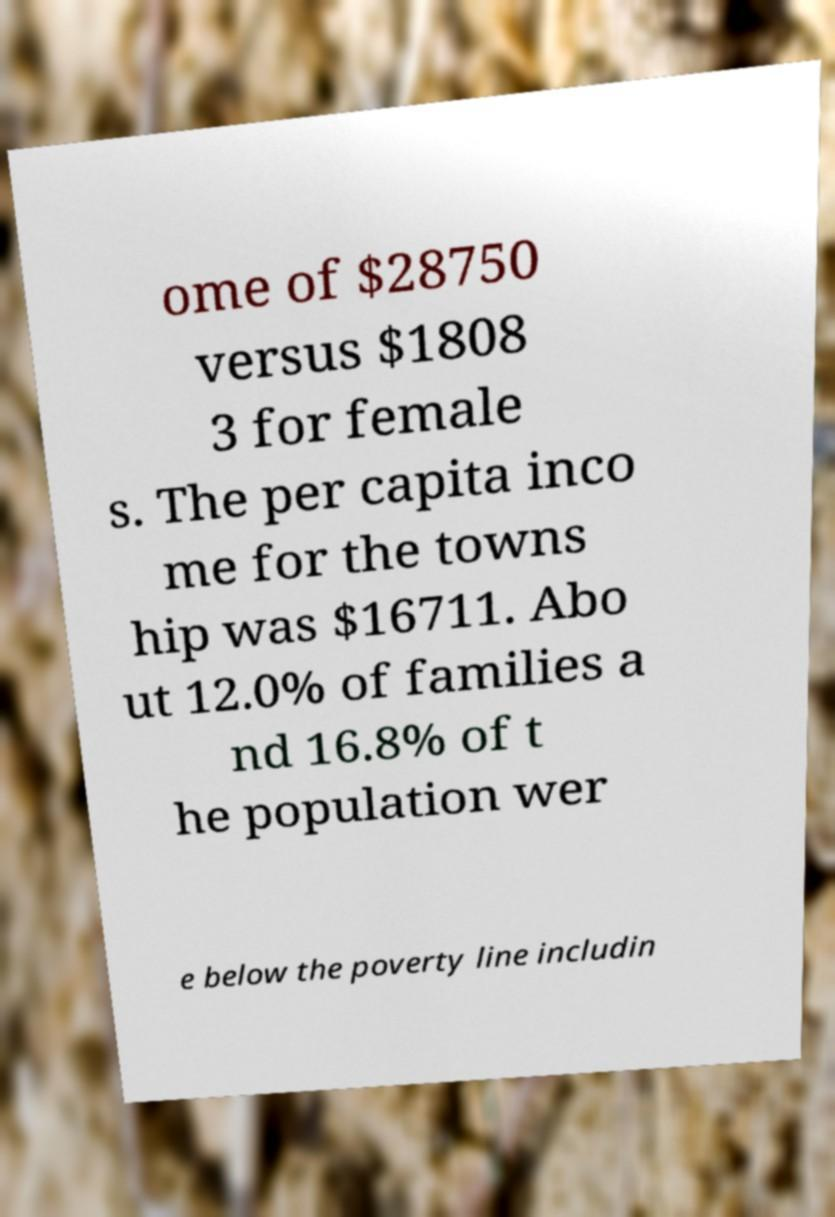Please identify and transcribe the text found in this image. ome of $28750 versus $1808 3 for female s. The per capita inco me for the towns hip was $16711. Abo ut 12.0% of families a nd 16.8% of t he population wer e below the poverty line includin 